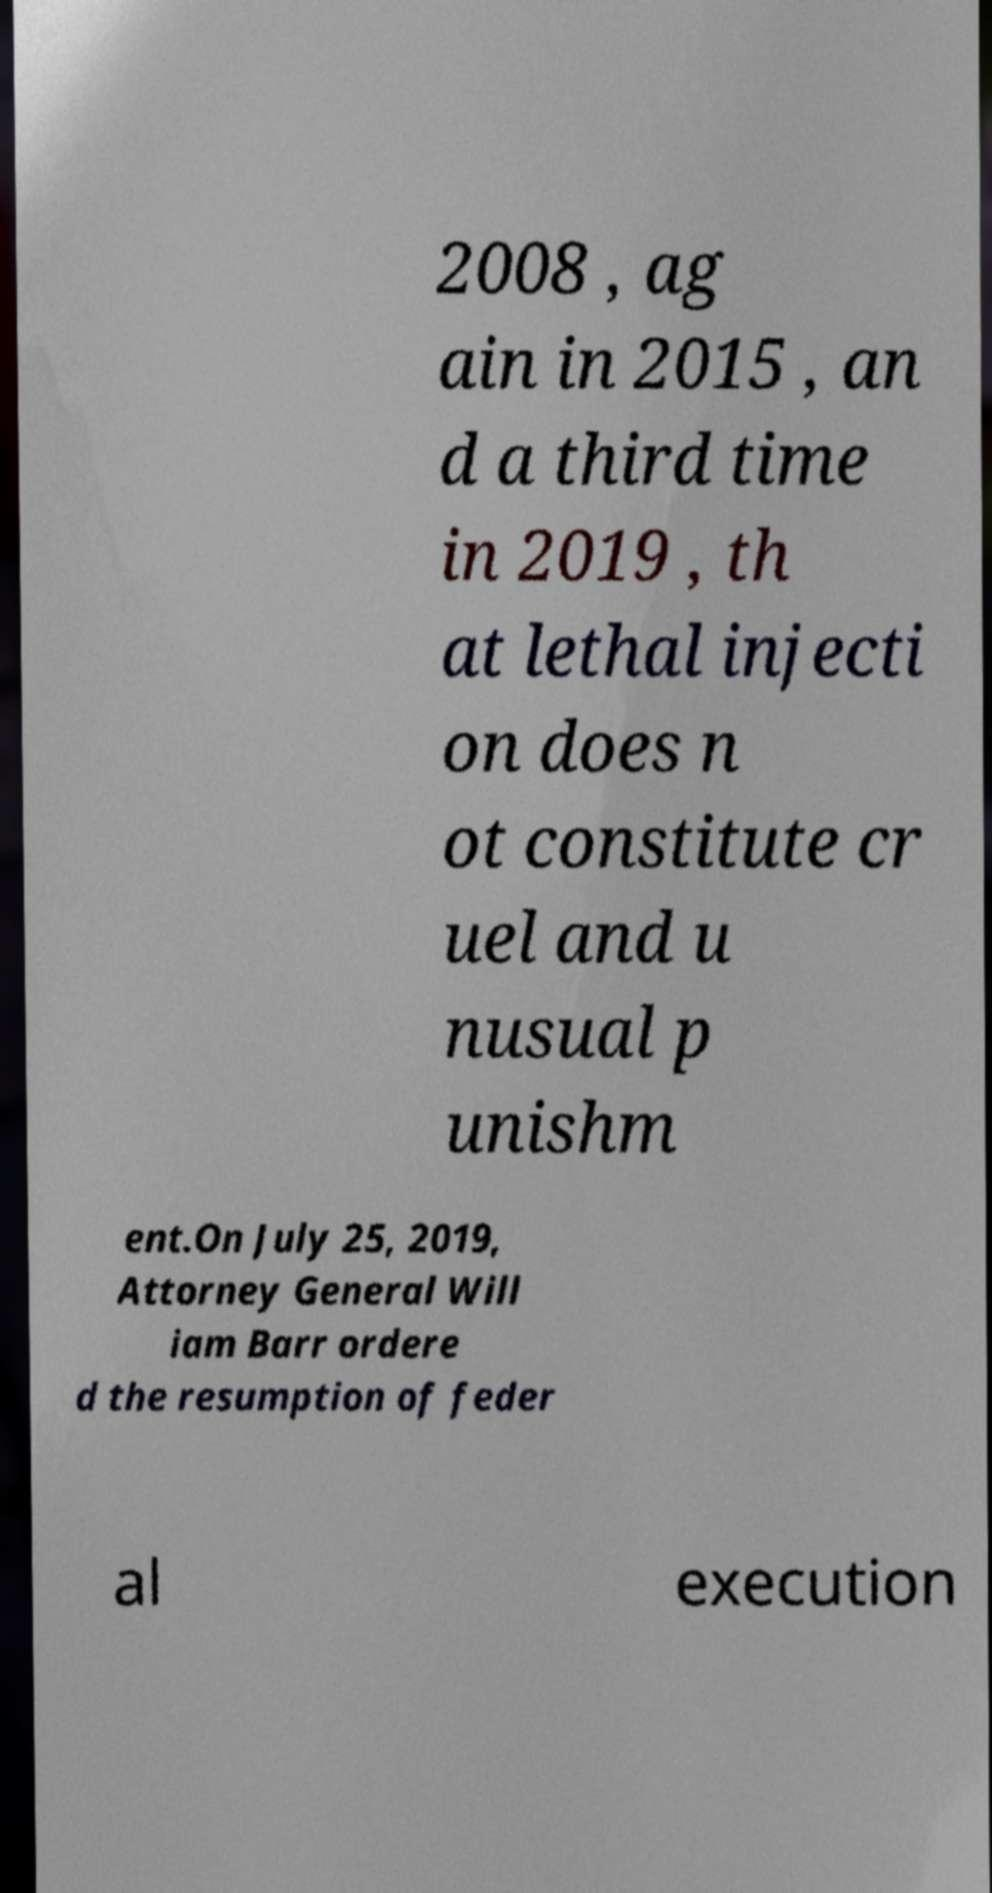What messages or text are displayed in this image? I need them in a readable, typed format. 2008 , ag ain in 2015 , an d a third time in 2019 , th at lethal injecti on does n ot constitute cr uel and u nusual p unishm ent.On July 25, 2019, Attorney General Will iam Barr ordere d the resumption of feder al execution 